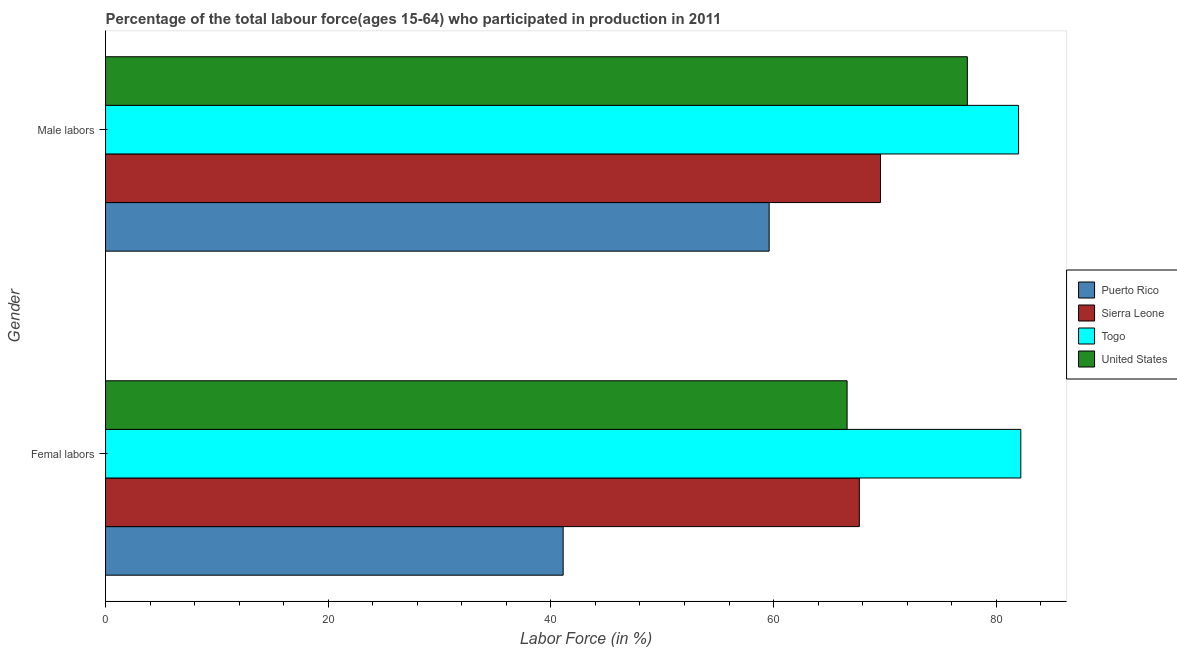Are the number of bars per tick equal to the number of legend labels?
Your answer should be very brief. Yes. Are the number of bars on each tick of the Y-axis equal?
Your response must be concise. Yes. What is the label of the 2nd group of bars from the top?
Your answer should be compact. Femal labors. What is the percentage of female labor force in Togo?
Offer a very short reply. 82.2. Across all countries, what is the minimum percentage of female labor force?
Keep it short and to the point. 41.1. In which country was the percentage of male labour force maximum?
Provide a short and direct response. Togo. In which country was the percentage of male labour force minimum?
Your answer should be very brief. Puerto Rico. What is the total percentage of male labour force in the graph?
Offer a very short reply. 288.6. What is the difference between the percentage of male labour force in Puerto Rico and that in Sierra Leone?
Your response must be concise. -10. What is the difference between the percentage of male labour force in United States and the percentage of female labor force in Puerto Rico?
Make the answer very short. 36.3. What is the average percentage of female labor force per country?
Offer a very short reply. 64.4. What is the difference between the percentage of male labour force and percentage of female labor force in United States?
Give a very brief answer. 10.8. In how many countries, is the percentage of male labour force greater than 52 %?
Make the answer very short. 4. What is the ratio of the percentage of male labour force in Togo to that in United States?
Your answer should be compact. 1.06. What does the 2nd bar from the top in Male labors represents?
Provide a succinct answer. Togo. What does the 2nd bar from the bottom in Femal labors represents?
Make the answer very short. Sierra Leone. How many bars are there?
Offer a very short reply. 8. Are the values on the major ticks of X-axis written in scientific E-notation?
Offer a very short reply. No. Does the graph contain any zero values?
Ensure brevity in your answer.  No. Does the graph contain grids?
Ensure brevity in your answer.  No. How many legend labels are there?
Give a very brief answer. 4. How are the legend labels stacked?
Your answer should be compact. Vertical. What is the title of the graph?
Ensure brevity in your answer.  Percentage of the total labour force(ages 15-64) who participated in production in 2011. What is the label or title of the X-axis?
Offer a very short reply. Labor Force (in %). What is the label or title of the Y-axis?
Keep it short and to the point. Gender. What is the Labor Force (in %) in Puerto Rico in Femal labors?
Your response must be concise. 41.1. What is the Labor Force (in %) of Sierra Leone in Femal labors?
Make the answer very short. 67.7. What is the Labor Force (in %) in Togo in Femal labors?
Your response must be concise. 82.2. What is the Labor Force (in %) in United States in Femal labors?
Your answer should be very brief. 66.6. What is the Labor Force (in %) in Puerto Rico in Male labors?
Make the answer very short. 59.6. What is the Labor Force (in %) in Sierra Leone in Male labors?
Your response must be concise. 69.6. What is the Labor Force (in %) in Togo in Male labors?
Ensure brevity in your answer.  82. What is the Labor Force (in %) in United States in Male labors?
Your answer should be very brief. 77.4. Across all Gender, what is the maximum Labor Force (in %) in Puerto Rico?
Provide a short and direct response. 59.6. Across all Gender, what is the maximum Labor Force (in %) of Sierra Leone?
Keep it short and to the point. 69.6. Across all Gender, what is the maximum Labor Force (in %) in Togo?
Provide a succinct answer. 82.2. Across all Gender, what is the maximum Labor Force (in %) in United States?
Give a very brief answer. 77.4. Across all Gender, what is the minimum Labor Force (in %) of Puerto Rico?
Provide a succinct answer. 41.1. Across all Gender, what is the minimum Labor Force (in %) of Sierra Leone?
Make the answer very short. 67.7. Across all Gender, what is the minimum Labor Force (in %) of United States?
Provide a succinct answer. 66.6. What is the total Labor Force (in %) in Puerto Rico in the graph?
Offer a terse response. 100.7. What is the total Labor Force (in %) of Sierra Leone in the graph?
Ensure brevity in your answer.  137.3. What is the total Labor Force (in %) of Togo in the graph?
Your answer should be compact. 164.2. What is the total Labor Force (in %) in United States in the graph?
Your answer should be very brief. 144. What is the difference between the Labor Force (in %) in Puerto Rico in Femal labors and that in Male labors?
Keep it short and to the point. -18.5. What is the difference between the Labor Force (in %) in Sierra Leone in Femal labors and that in Male labors?
Your answer should be very brief. -1.9. What is the difference between the Labor Force (in %) in United States in Femal labors and that in Male labors?
Ensure brevity in your answer.  -10.8. What is the difference between the Labor Force (in %) in Puerto Rico in Femal labors and the Labor Force (in %) in Sierra Leone in Male labors?
Make the answer very short. -28.5. What is the difference between the Labor Force (in %) in Puerto Rico in Femal labors and the Labor Force (in %) in Togo in Male labors?
Ensure brevity in your answer.  -40.9. What is the difference between the Labor Force (in %) of Puerto Rico in Femal labors and the Labor Force (in %) of United States in Male labors?
Your answer should be compact. -36.3. What is the difference between the Labor Force (in %) of Sierra Leone in Femal labors and the Labor Force (in %) of Togo in Male labors?
Offer a terse response. -14.3. What is the average Labor Force (in %) of Puerto Rico per Gender?
Your response must be concise. 50.35. What is the average Labor Force (in %) of Sierra Leone per Gender?
Make the answer very short. 68.65. What is the average Labor Force (in %) in Togo per Gender?
Provide a short and direct response. 82.1. What is the difference between the Labor Force (in %) of Puerto Rico and Labor Force (in %) of Sierra Leone in Femal labors?
Your answer should be compact. -26.6. What is the difference between the Labor Force (in %) of Puerto Rico and Labor Force (in %) of Togo in Femal labors?
Ensure brevity in your answer.  -41.1. What is the difference between the Labor Force (in %) of Puerto Rico and Labor Force (in %) of United States in Femal labors?
Provide a short and direct response. -25.5. What is the difference between the Labor Force (in %) in Sierra Leone and Labor Force (in %) in Togo in Femal labors?
Make the answer very short. -14.5. What is the difference between the Labor Force (in %) in Togo and Labor Force (in %) in United States in Femal labors?
Provide a succinct answer. 15.6. What is the difference between the Labor Force (in %) of Puerto Rico and Labor Force (in %) of Togo in Male labors?
Give a very brief answer. -22.4. What is the difference between the Labor Force (in %) of Puerto Rico and Labor Force (in %) of United States in Male labors?
Offer a terse response. -17.8. What is the difference between the Labor Force (in %) of Sierra Leone and Labor Force (in %) of United States in Male labors?
Offer a very short reply. -7.8. What is the difference between the Labor Force (in %) in Togo and Labor Force (in %) in United States in Male labors?
Offer a very short reply. 4.6. What is the ratio of the Labor Force (in %) in Puerto Rico in Femal labors to that in Male labors?
Provide a short and direct response. 0.69. What is the ratio of the Labor Force (in %) of Sierra Leone in Femal labors to that in Male labors?
Provide a short and direct response. 0.97. What is the ratio of the Labor Force (in %) of United States in Femal labors to that in Male labors?
Provide a short and direct response. 0.86. What is the difference between the highest and the second highest Labor Force (in %) in Sierra Leone?
Make the answer very short. 1.9. What is the difference between the highest and the second highest Labor Force (in %) in Togo?
Your answer should be compact. 0.2. What is the difference between the highest and the lowest Labor Force (in %) of Puerto Rico?
Make the answer very short. 18.5. What is the difference between the highest and the lowest Labor Force (in %) of Sierra Leone?
Offer a terse response. 1.9. What is the difference between the highest and the lowest Labor Force (in %) in United States?
Offer a terse response. 10.8. 